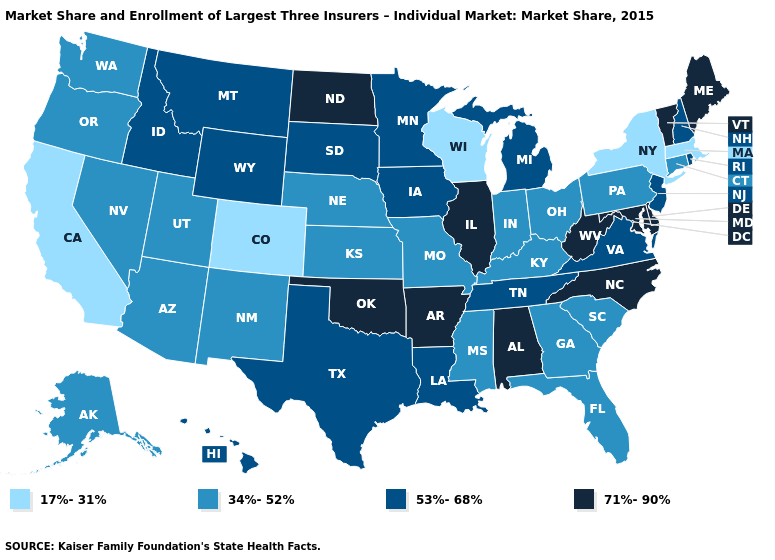What is the value of Florida?
Concise answer only. 34%-52%. Does Wisconsin have the lowest value in the USA?
Concise answer only. Yes. Does the first symbol in the legend represent the smallest category?
Write a very short answer. Yes. What is the value of Texas?
Quick response, please. 53%-68%. Name the states that have a value in the range 17%-31%?
Give a very brief answer. California, Colorado, Massachusetts, New York, Wisconsin. Name the states that have a value in the range 34%-52%?
Keep it brief. Alaska, Arizona, Connecticut, Florida, Georgia, Indiana, Kansas, Kentucky, Mississippi, Missouri, Nebraska, Nevada, New Mexico, Ohio, Oregon, Pennsylvania, South Carolina, Utah, Washington. What is the lowest value in the USA?
Be succinct. 17%-31%. Does the map have missing data?
Quick response, please. No. Among the states that border Michigan , which have the highest value?
Keep it brief. Indiana, Ohio. Does Maryland have the highest value in the South?
Concise answer only. Yes. What is the value of Pennsylvania?
Short answer required. 34%-52%. Name the states that have a value in the range 71%-90%?
Quick response, please. Alabama, Arkansas, Delaware, Illinois, Maine, Maryland, North Carolina, North Dakota, Oklahoma, Vermont, West Virginia. Among the states that border South Carolina , which have the highest value?
Quick response, please. North Carolina. Does South Dakota have the highest value in the USA?
Give a very brief answer. No. Name the states that have a value in the range 71%-90%?
Concise answer only. Alabama, Arkansas, Delaware, Illinois, Maine, Maryland, North Carolina, North Dakota, Oklahoma, Vermont, West Virginia. 